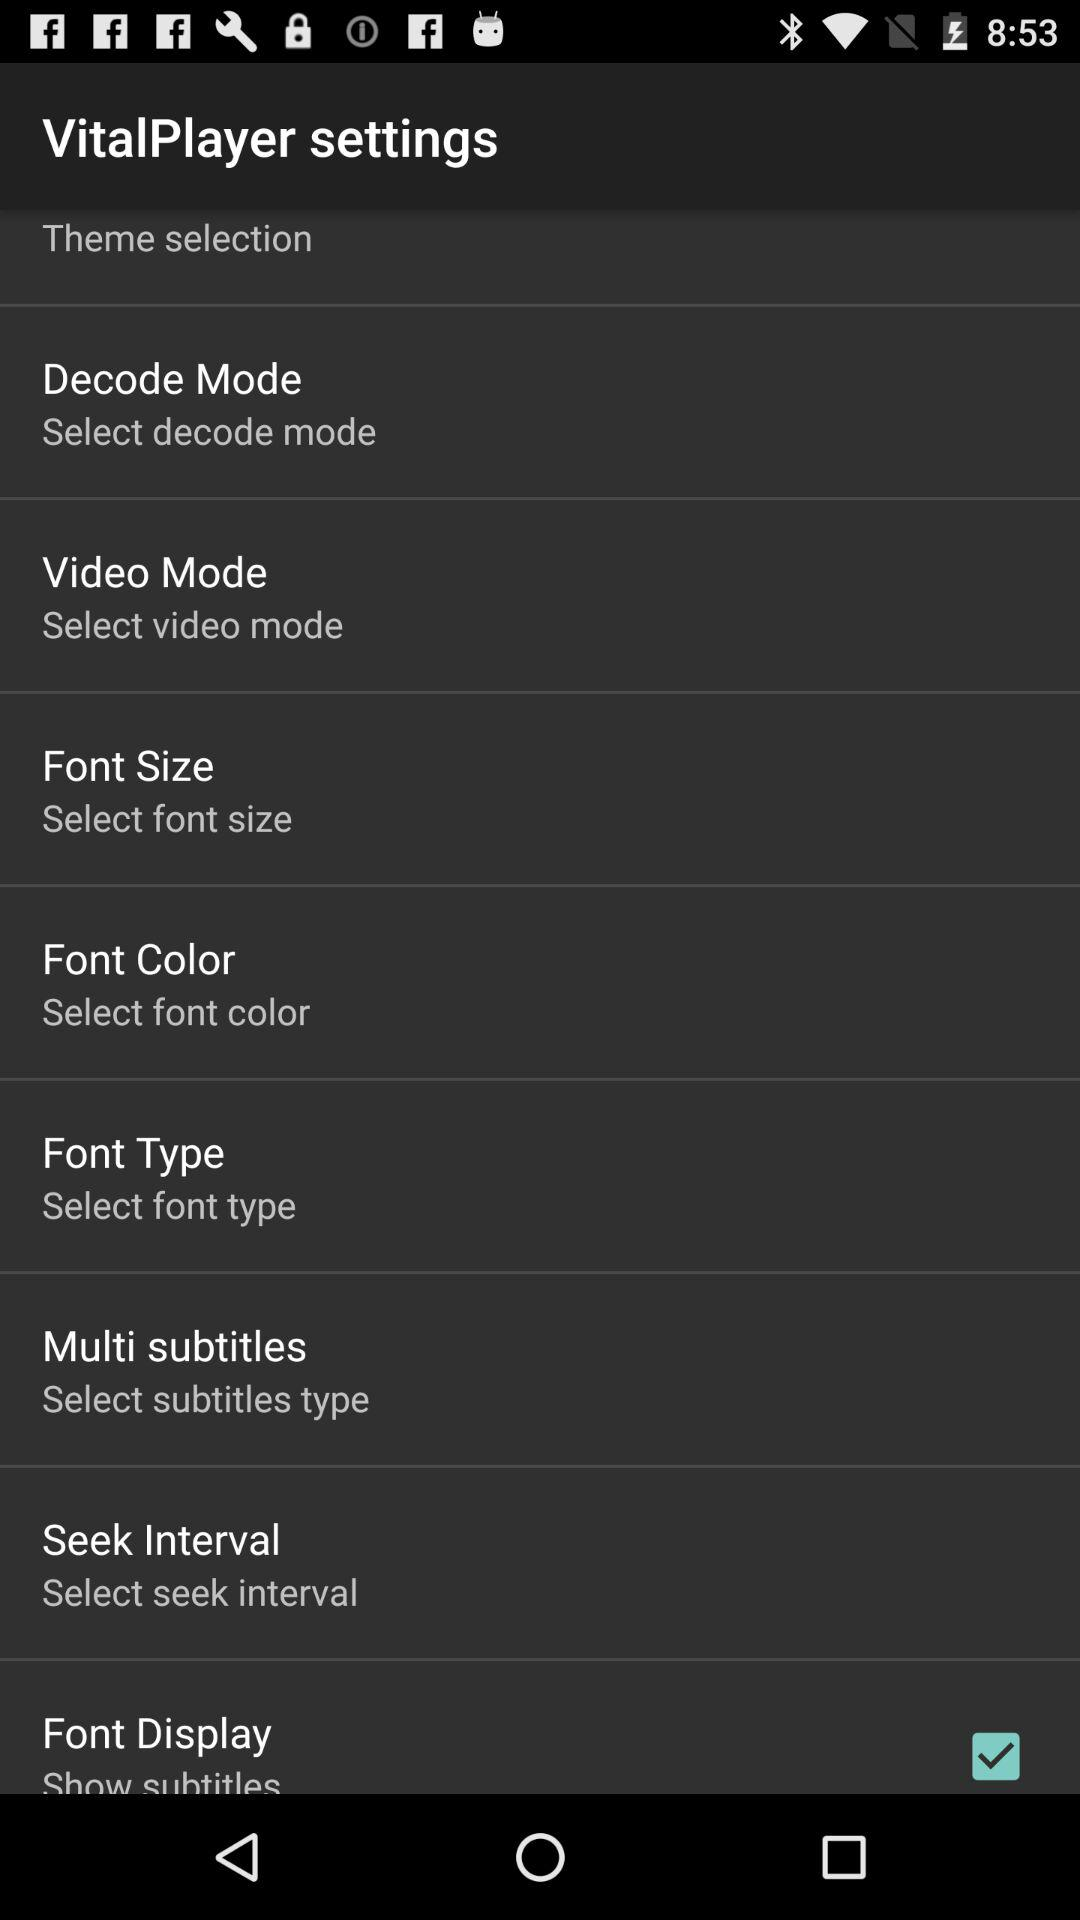What is the name of the application? The application shown in the image is called 'VitalPlayer.' It appears to be a media player with customizable settings such as theme selection, decode mode, video mode, and options for subtitles, indicating its utility for playing video files with various customization options. 